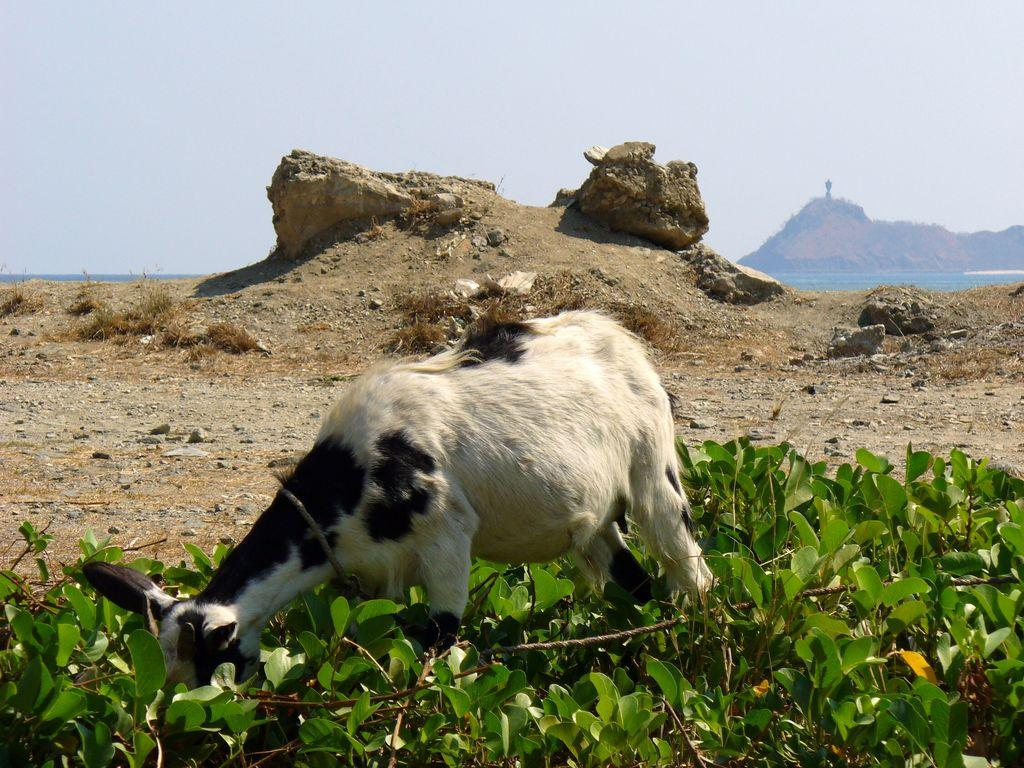What type of creature is present in the image? A: There is an animal in the image. What is the animal doing in the image? The animal is eating plants. What other objects can be seen in the image? There are stones visible in the image. What is visible at the top of the image? The sky is visible at the top of the image. What type of discussion is taking place between the animal and the seashore in the image? There is no discussion taking place in the image, and there is no seashore present. 